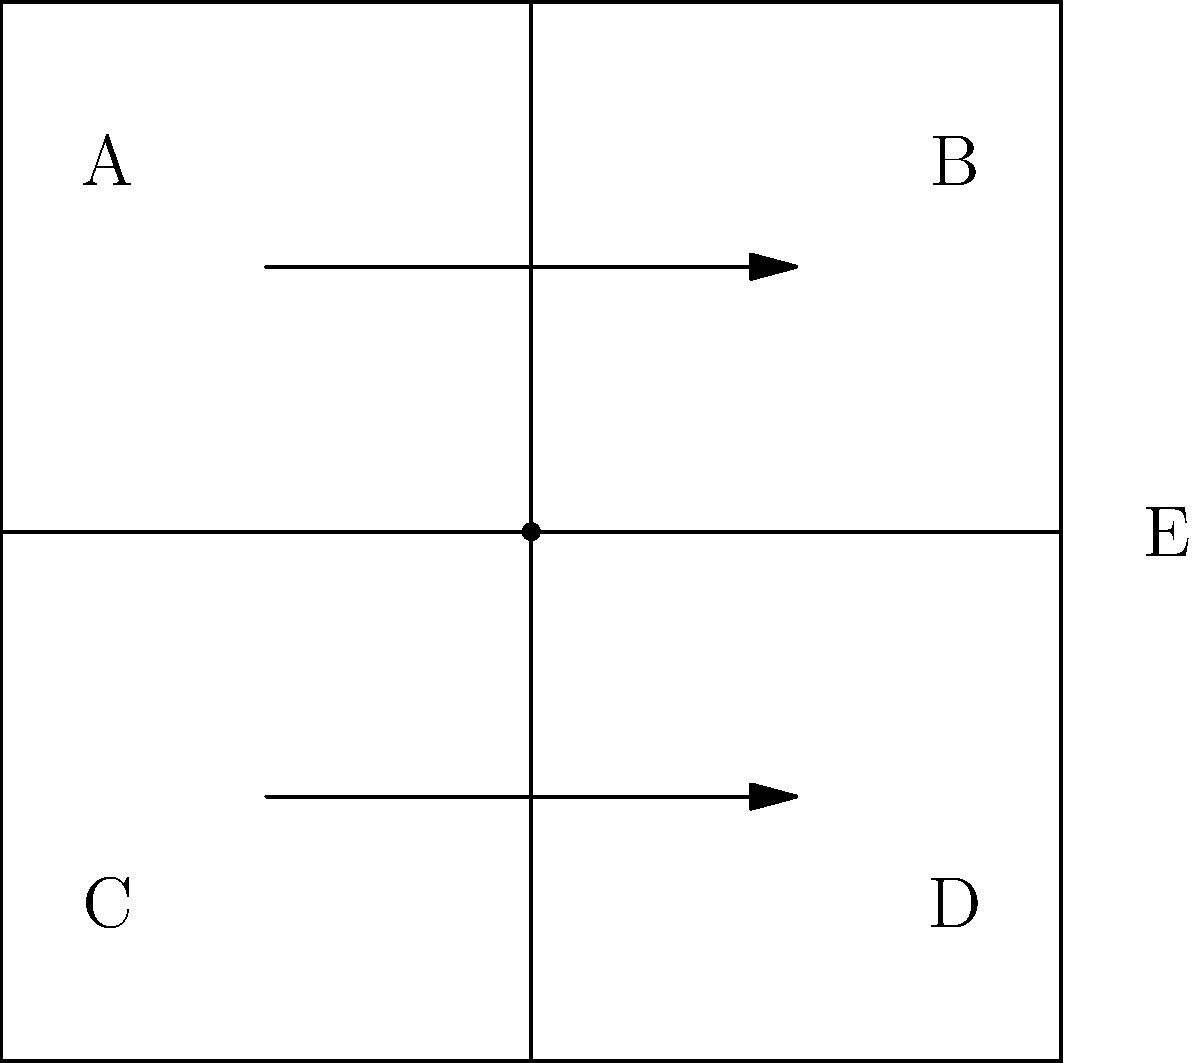In the given wiring diagram, which critical element is missing according to proper labeling and documentation requirements for regulatory compliance? To assess this wiring diagram for proper labeling and documentation requirements, we need to follow these steps:

1. Identify all components: The diagram shows a rectangular enclosure with four quadrants (A, B, C, D) and two arrows indicating current flow or connections.

2. Check for labels: We can see labels A, B, C, D, and E properly placed to identify different sections or terminals.

3. Examine connection points: There is a prominent dot at the center of the diagram where the lines intersect.

4. Verify labeling completeness: While most elements are labeled, the central connection point (dot) lacks a label.

5. Understand regulatory requirements: In electrical engineering, all connection points, especially those where multiple wires meet, must be clearly labeled for safety and troubleshooting purposes.

6. Identify the missing element: The central connection point, being a critical juncture in the wiring diagram, requires a label to comply with proper documentation standards.

Therefore, the missing critical element in this diagram is a label for the central connection point, which is essential for regulatory compliance and proper documentation.
Answer: Label for central connection point 